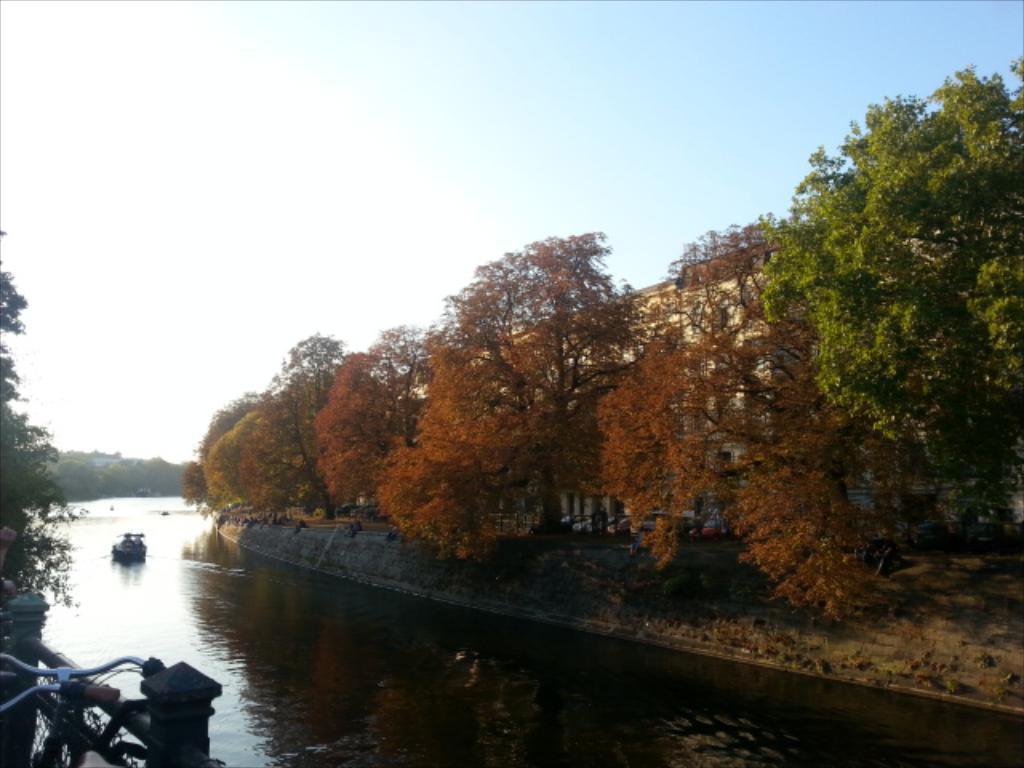Describe this image in one or two sentences. In this image there is a lake in the middle. In the lake there is a boat. There are trees on either side of the lake. At the top there is the sky. On the right side there is a building behind the trees. On the left side bottom there is a cycle parked near the fence. 